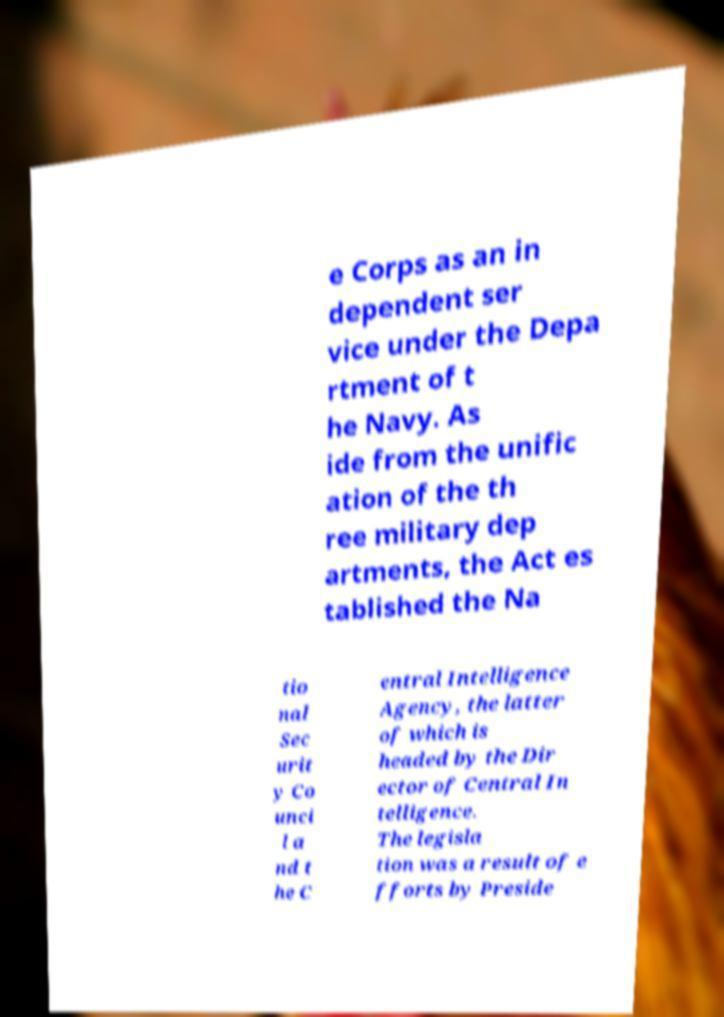Please identify and transcribe the text found in this image. e Corps as an in dependent ser vice under the Depa rtment of t he Navy. As ide from the unific ation of the th ree military dep artments, the Act es tablished the Na tio nal Sec urit y Co unci l a nd t he C entral Intelligence Agency, the latter of which is headed by the Dir ector of Central In telligence. The legisla tion was a result of e fforts by Preside 